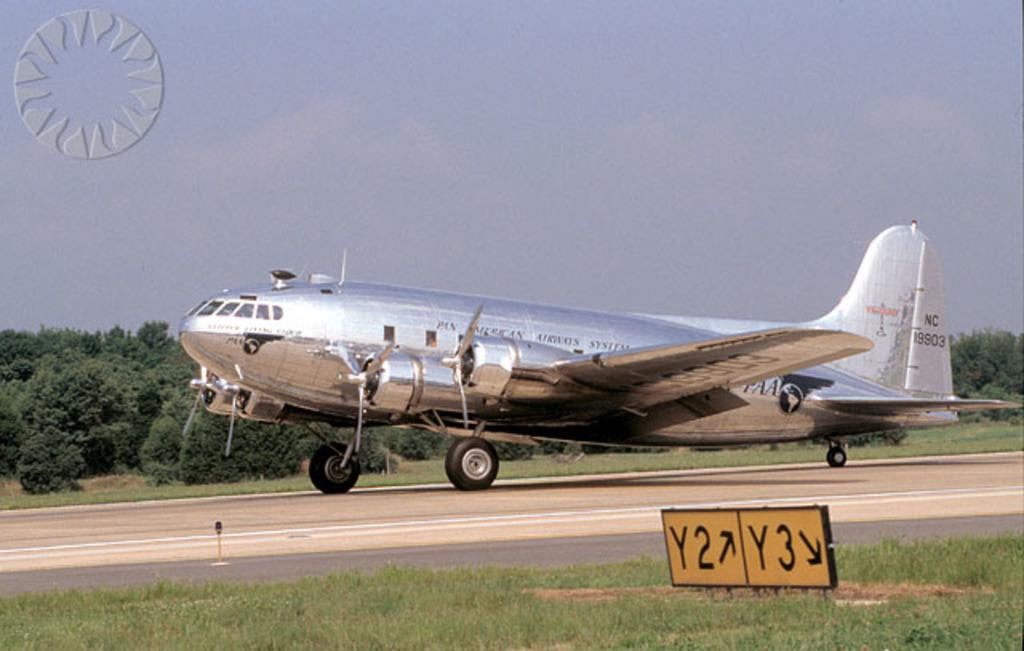<image>
Create a compact narrative representing the image presented. The yellow runway signs have arrows to point out where Y2 and Y3 are. 